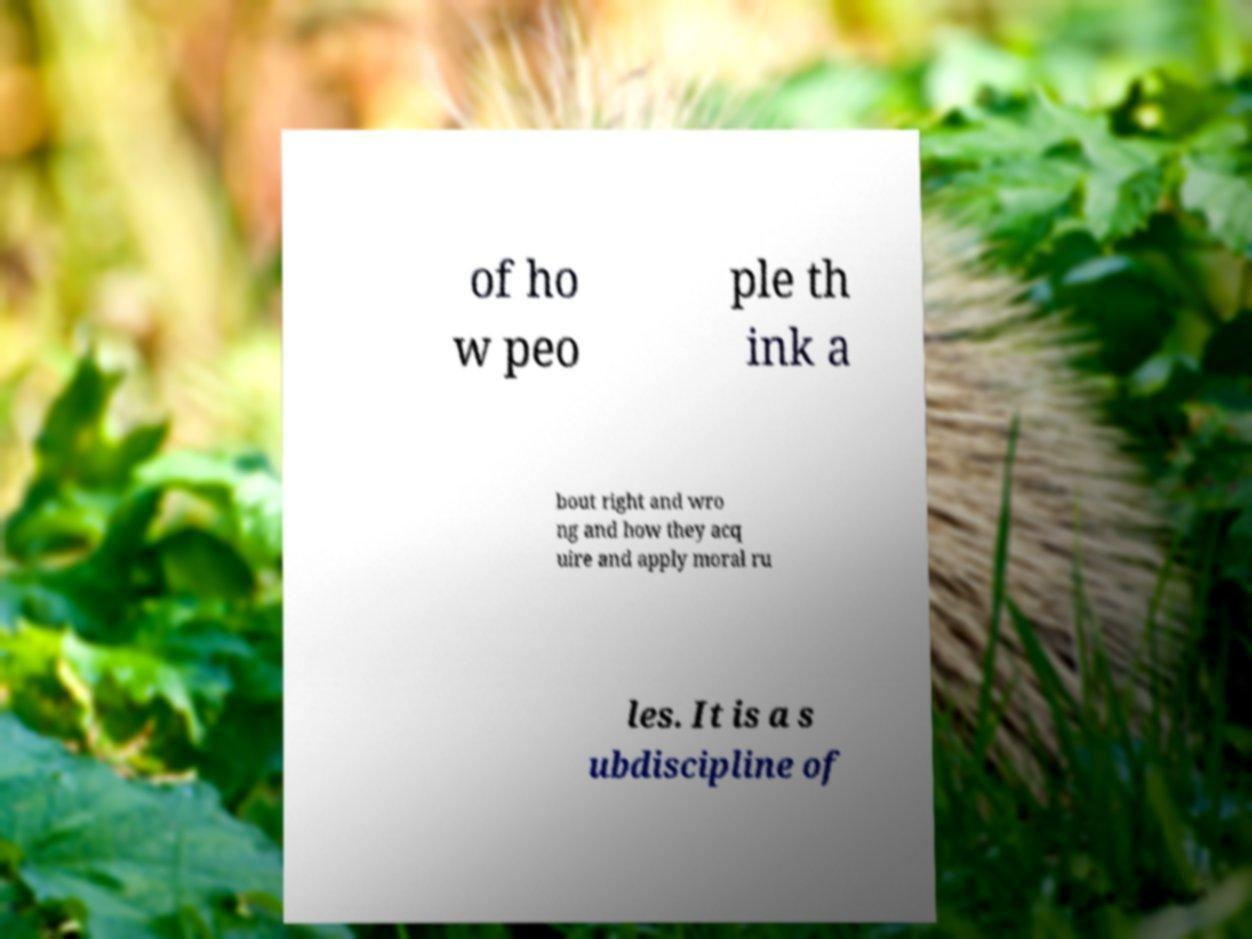Can you accurately transcribe the text from the provided image for me? of ho w peo ple th ink a bout right and wro ng and how they acq uire and apply moral ru les. It is a s ubdiscipline of 